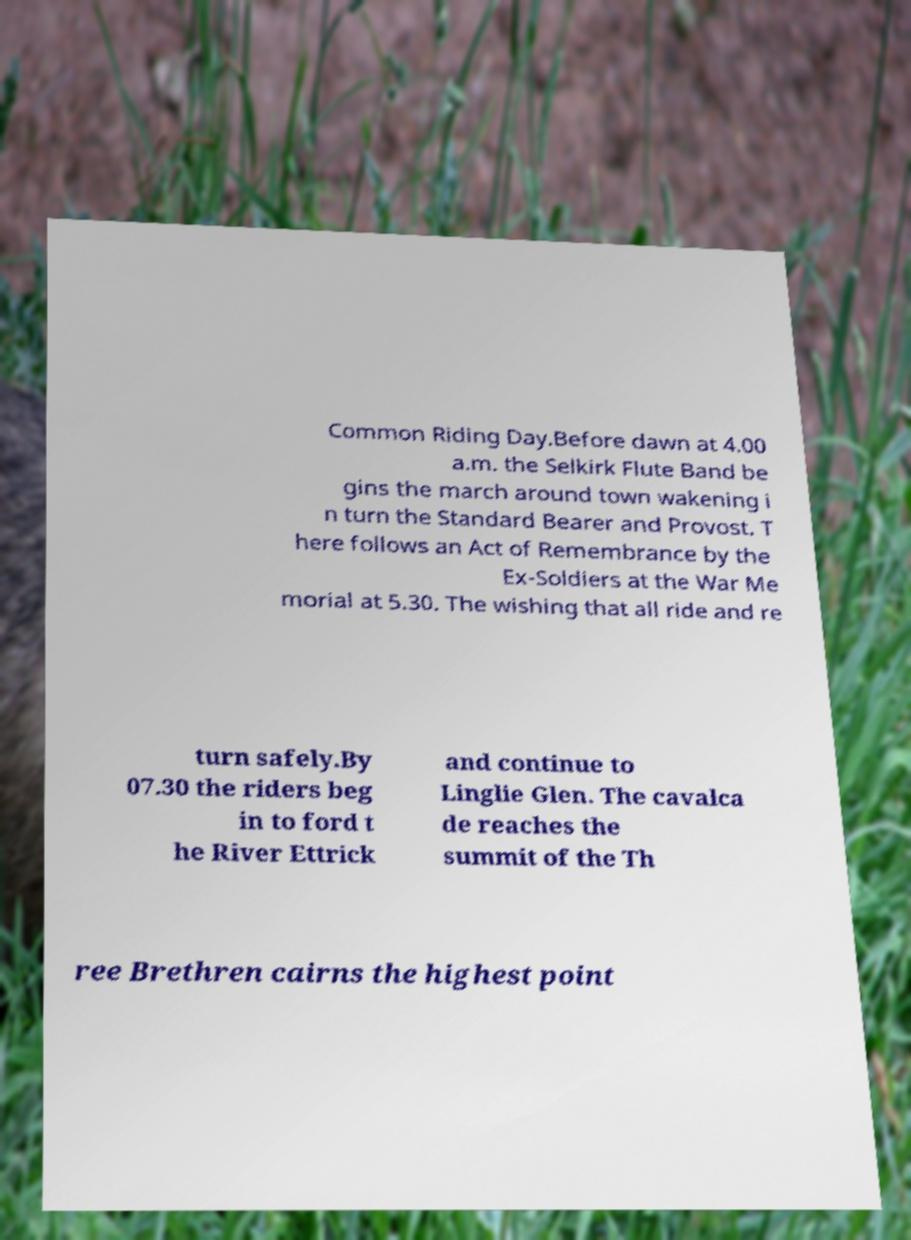Please read and relay the text visible in this image. What does it say? Common Riding Day.Before dawn at 4.00 a.m. the Selkirk Flute Band be gins the march around town wakening i n turn the Standard Bearer and Provost. T here follows an Act of Remembrance by the Ex-Soldiers at the War Me morial at 5.30. The wishing that all ride and re turn safely.By 07.30 the riders beg in to ford t he River Ettrick and continue to Linglie Glen. The cavalca de reaches the summit of the Th ree Brethren cairns the highest point 